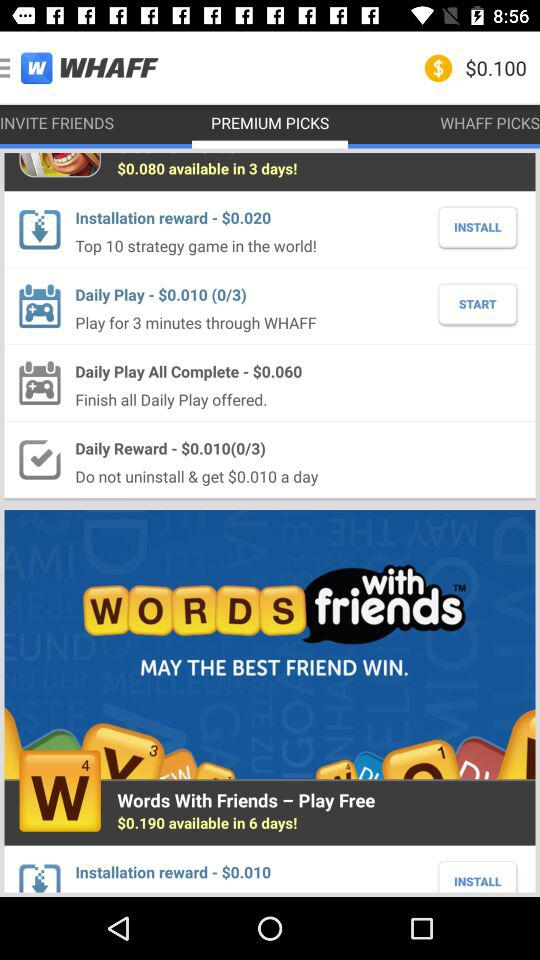What is the application name? The application name is "WHAFF". 